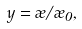<formula> <loc_0><loc_0><loc_500><loc_500>y = \rho / \rho _ { 0 } ,</formula> 